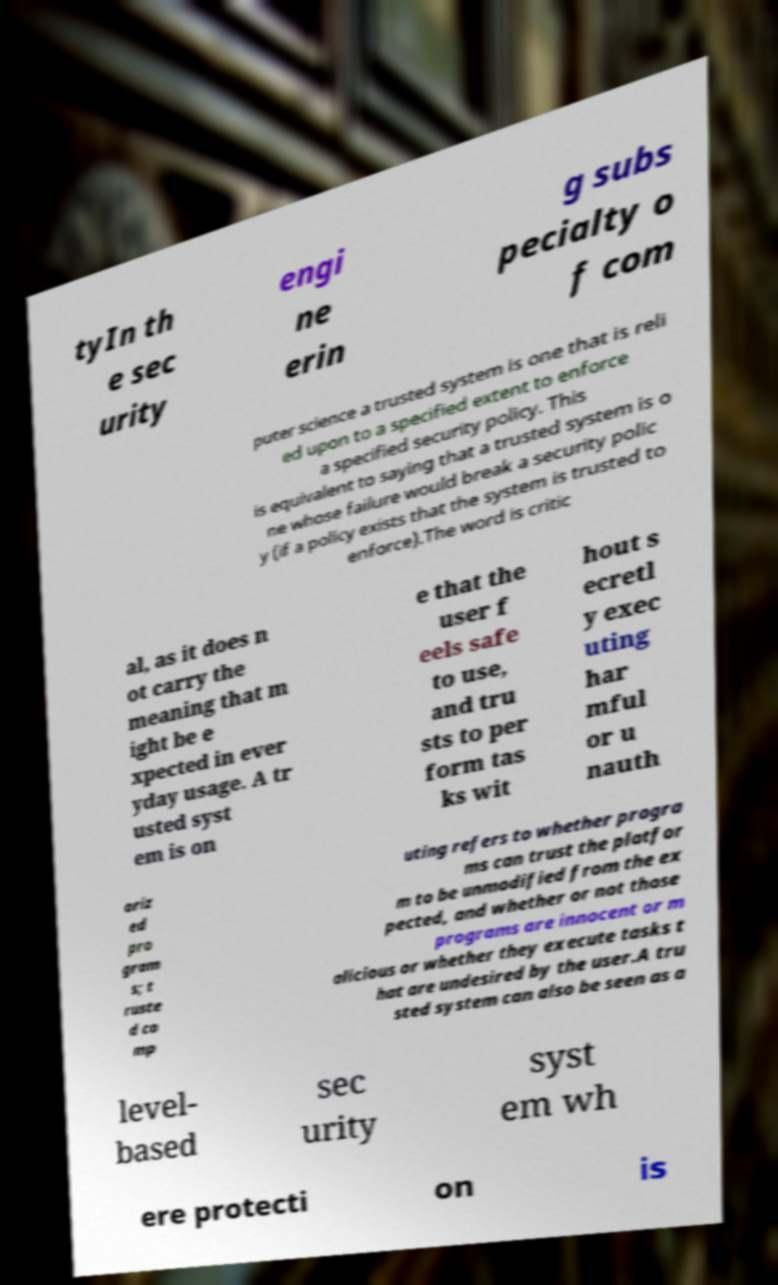Could you assist in decoding the text presented in this image and type it out clearly? tyIn th e sec urity engi ne erin g subs pecialty o f com puter science a trusted system is one that is reli ed upon to a specified extent to enforce a specified security policy. This is equivalent to saying that a trusted system is o ne whose failure would break a security polic y (if a policy exists that the system is trusted to enforce).The word is critic al, as it does n ot carry the meaning that m ight be e xpected in ever yday usage. A tr usted syst em is on e that the user f eels safe to use, and tru sts to per form tas ks wit hout s ecretl y exec uting har mful or u nauth oriz ed pro gram s; t ruste d co mp uting refers to whether progra ms can trust the platfor m to be unmodified from the ex pected, and whether or not those programs are innocent or m alicious or whether they execute tasks t hat are undesired by the user.A tru sted system can also be seen as a level- based sec urity syst em wh ere protecti on is 